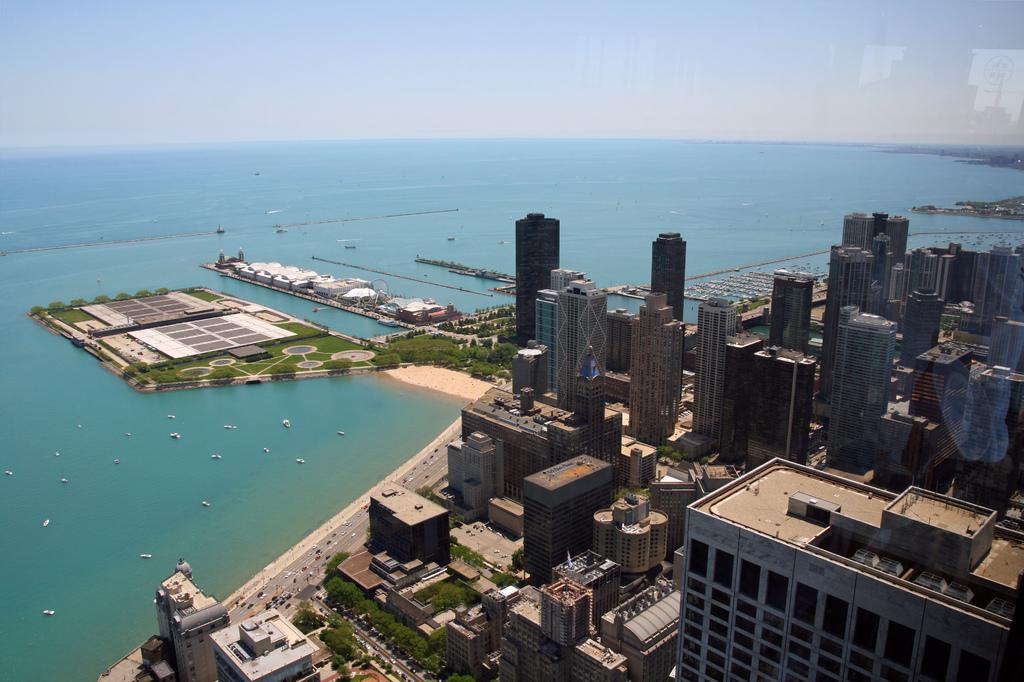What is the perspective of the image? The image is taken from a top view. What can be seen in the image from this perspective? There are many buildings, trees, vehicles on the road, the sea, grass, and the sky visible in the image. How many types of natural elements are present in the image? There are three types of natural elements present in the image: trees, grass, and the sea. What is the condition of the sky in the image? The sky is visible in the image. What type of fruit can be seen growing on the trees in the image? There is no fruit visible on the trees in the image. What type of smoke can be seen coming from the buildings in the image? There is no smoke coming from the buildings in the image. 